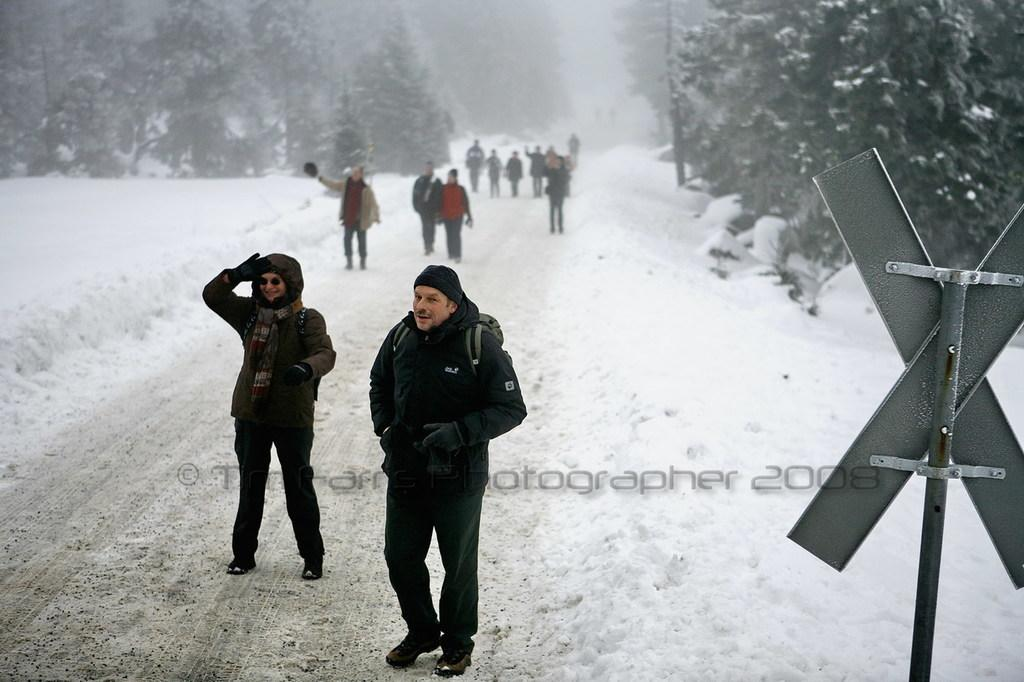What is the main subject in the middle of the image? There is a person in the middle of the image. Can you describe any additional features of the image? There is a watermark in the image, and trees are visible. What is the weather like in the image? There is snow visible on either side of the image, indicating a cold or wintery environment. What might the board on the right side of the image be used for? The board on the right side of the image could be used for various purposes, such as a sign or a notice board. What type of flesh can be seen on the person's face in the image? There is no flesh visible on the person's face in the image, as it is a photograph and not a physical representation. 